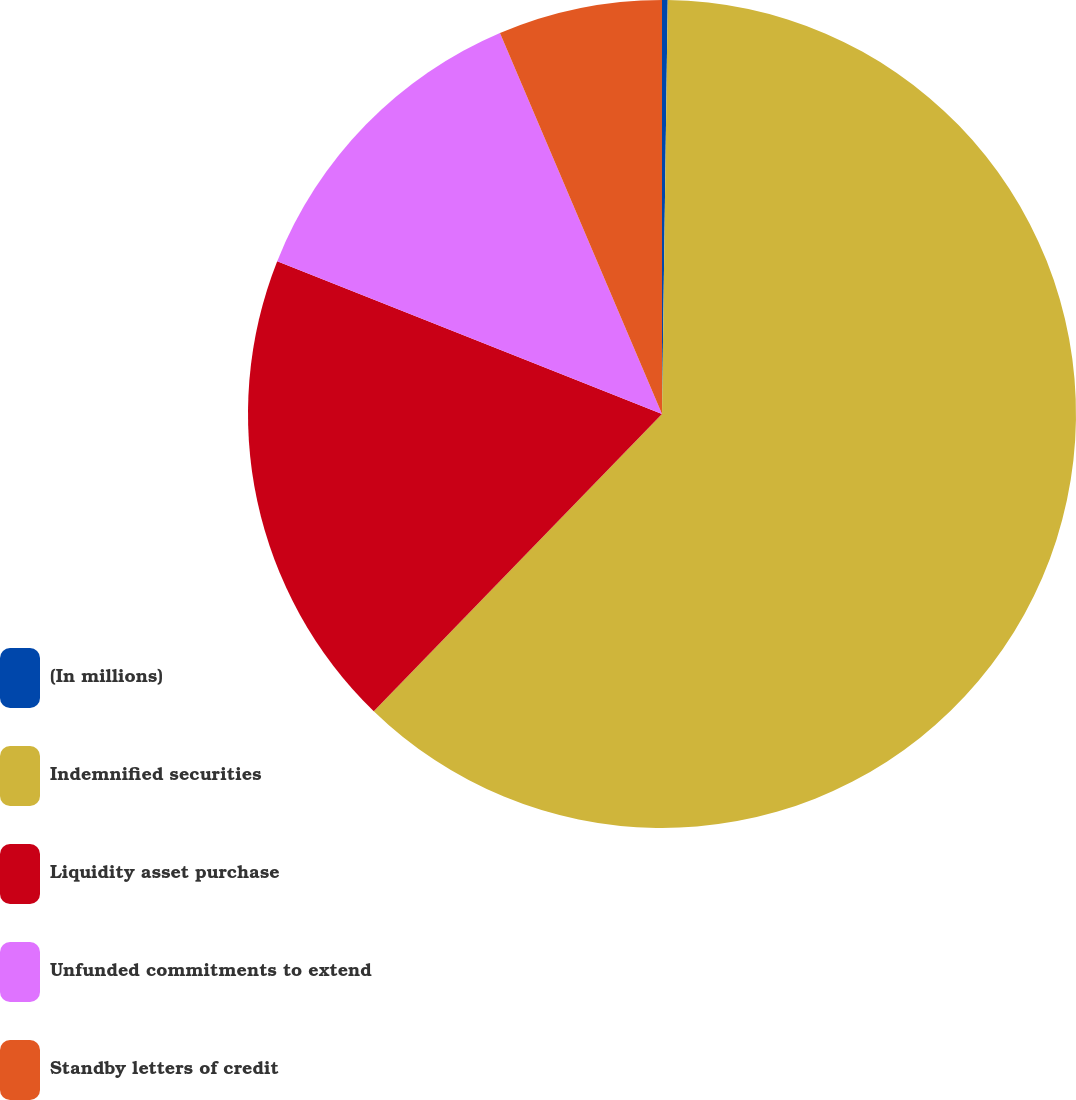<chart> <loc_0><loc_0><loc_500><loc_500><pie_chart><fcel>(In millions)<fcel>Indemnified securities<fcel>Liquidity asset purchase<fcel>Unfunded commitments to extend<fcel>Standby letters of credit<nl><fcel>0.22%<fcel>62.03%<fcel>18.76%<fcel>12.58%<fcel>6.4%<nl></chart> 